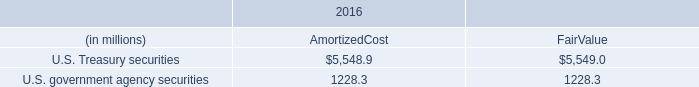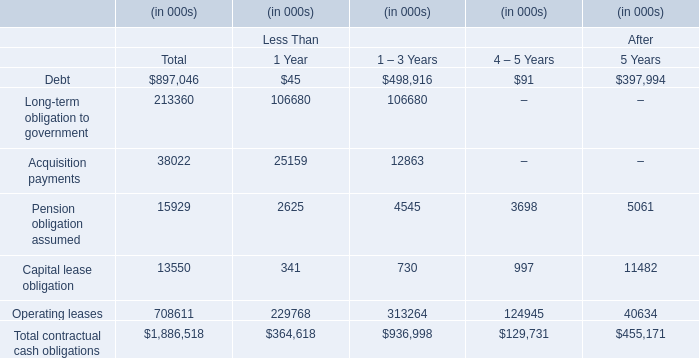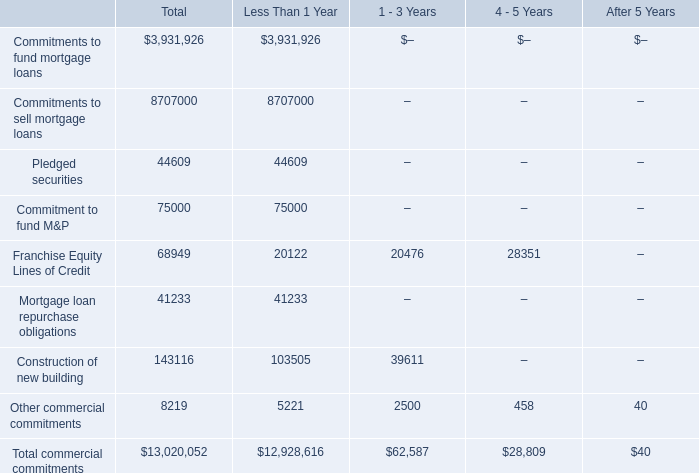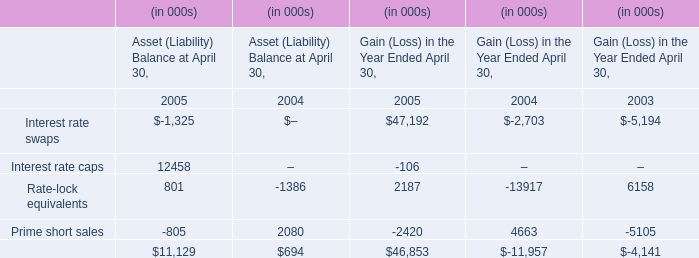What is the sum of the Acquisition payments in the period section where Operating leases is the highest? (in thousand) 
Answer: 12863. 